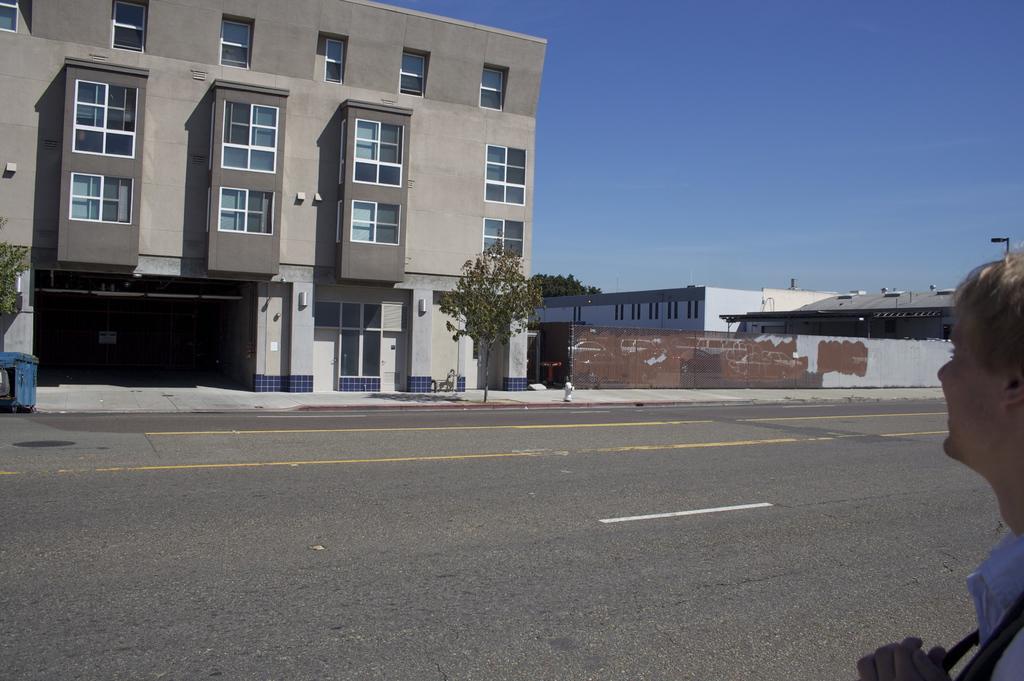Describe this image in one or two sentences. In the foreground I can see a person on the road. In the background I can see buildings, windows, trees, fence, light pole, vehicle and the sky. This image is taken may be during a day. 